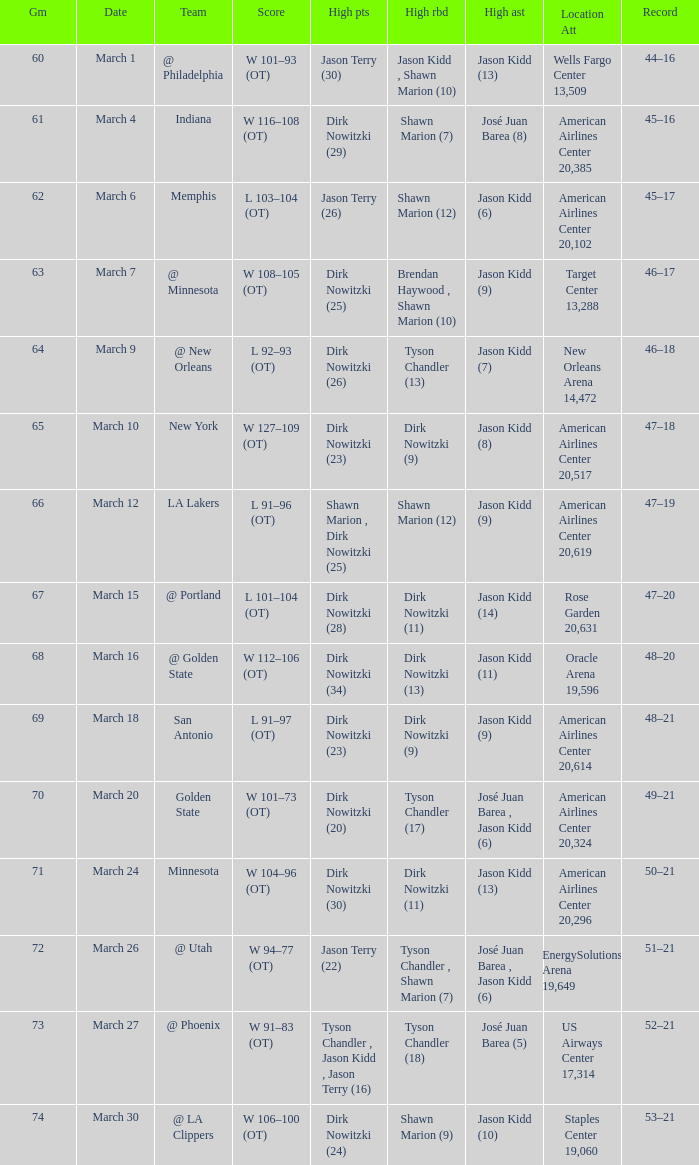Name the high assists for  l 103–104 (ot) Jason Kidd (6). 